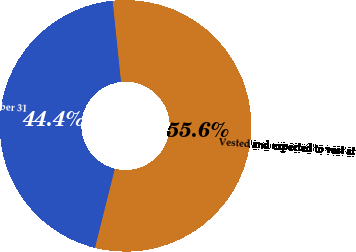Convert chart. <chart><loc_0><loc_0><loc_500><loc_500><pie_chart><fcel>Vested and expected to vest at<fcel>Exercisable at December 31<nl><fcel>55.56%<fcel>44.44%<nl></chart> 